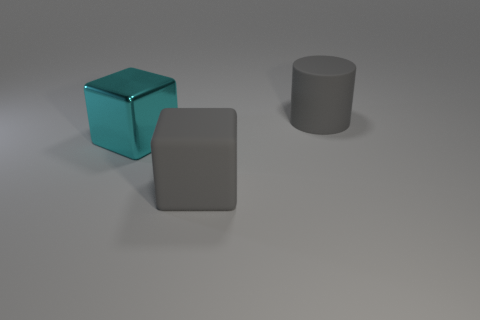Are there any gray cylinders that are right of the large gray matte thing behind the cyan object?
Give a very brief answer. No. How many large gray matte things are behind the big rubber block and to the left of the large cylinder?
Offer a very short reply. 0. There is a matte object behind the cyan shiny cube; what shape is it?
Keep it short and to the point. Cylinder. How many gray rubber blocks are the same size as the cyan shiny thing?
Make the answer very short. 1. Do the matte thing right of the big rubber cube and the large matte cube have the same color?
Offer a very short reply. Yes. What material is the big thing that is to the right of the big cyan metal thing and on the left side of the gray rubber cylinder?
Keep it short and to the point. Rubber. Is the number of cyan matte things greater than the number of big gray rubber cubes?
Ensure brevity in your answer.  No. What is the color of the big matte object that is left of the gray thing on the right side of the large cube that is to the right of the cyan object?
Offer a very short reply. Gray. Are the gray object on the left side of the gray cylinder and the big cylinder made of the same material?
Keep it short and to the point. Yes. Are there any large metal things of the same color as the matte cylinder?
Make the answer very short. No. 